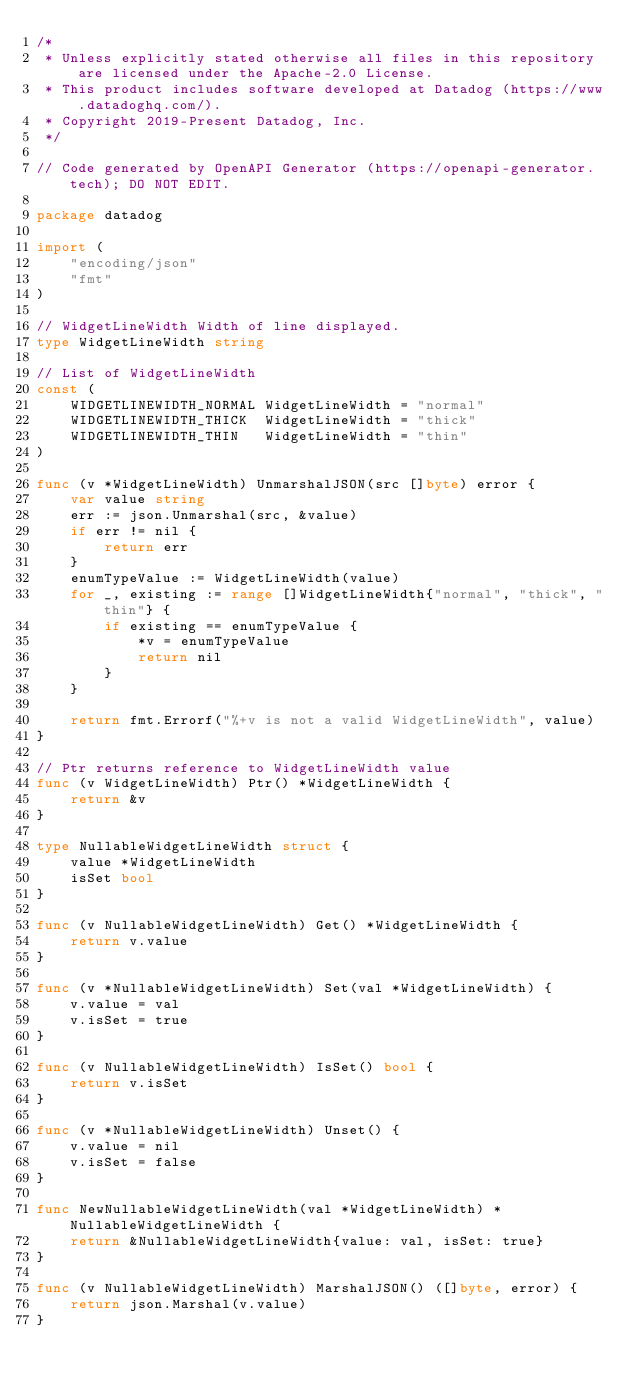Convert code to text. <code><loc_0><loc_0><loc_500><loc_500><_Go_>/*
 * Unless explicitly stated otherwise all files in this repository are licensed under the Apache-2.0 License.
 * This product includes software developed at Datadog (https://www.datadoghq.com/).
 * Copyright 2019-Present Datadog, Inc.
 */

// Code generated by OpenAPI Generator (https://openapi-generator.tech); DO NOT EDIT.

package datadog

import (
	"encoding/json"
	"fmt"
)

// WidgetLineWidth Width of line displayed.
type WidgetLineWidth string

// List of WidgetLineWidth
const (
	WIDGETLINEWIDTH_NORMAL WidgetLineWidth = "normal"
	WIDGETLINEWIDTH_THICK  WidgetLineWidth = "thick"
	WIDGETLINEWIDTH_THIN   WidgetLineWidth = "thin"
)

func (v *WidgetLineWidth) UnmarshalJSON(src []byte) error {
	var value string
	err := json.Unmarshal(src, &value)
	if err != nil {
		return err
	}
	enumTypeValue := WidgetLineWidth(value)
	for _, existing := range []WidgetLineWidth{"normal", "thick", "thin"} {
		if existing == enumTypeValue {
			*v = enumTypeValue
			return nil
		}
	}

	return fmt.Errorf("%+v is not a valid WidgetLineWidth", value)
}

// Ptr returns reference to WidgetLineWidth value
func (v WidgetLineWidth) Ptr() *WidgetLineWidth {
	return &v
}

type NullableWidgetLineWidth struct {
	value *WidgetLineWidth
	isSet bool
}

func (v NullableWidgetLineWidth) Get() *WidgetLineWidth {
	return v.value
}

func (v *NullableWidgetLineWidth) Set(val *WidgetLineWidth) {
	v.value = val
	v.isSet = true
}

func (v NullableWidgetLineWidth) IsSet() bool {
	return v.isSet
}

func (v *NullableWidgetLineWidth) Unset() {
	v.value = nil
	v.isSet = false
}

func NewNullableWidgetLineWidth(val *WidgetLineWidth) *NullableWidgetLineWidth {
	return &NullableWidgetLineWidth{value: val, isSet: true}
}

func (v NullableWidgetLineWidth) MarshalJSON() ([]byte, error) {
	return json.Marshal(v.value)
}
</code> 